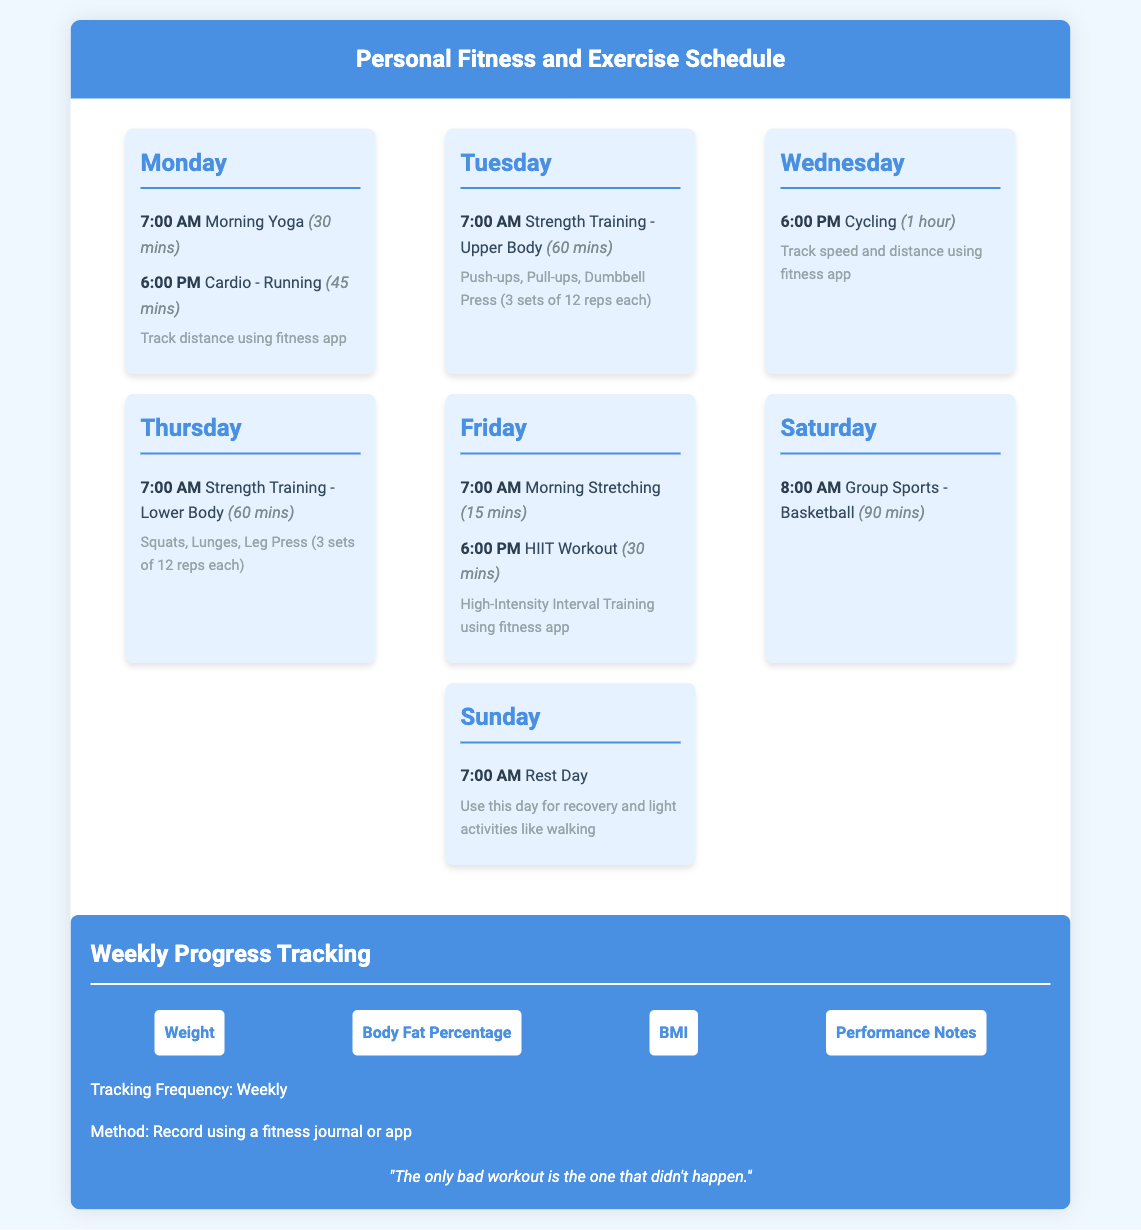What workout is scheduled for Monday at 7:00 AM? The document specifies that on Monday at 7:00 AM, there is a Morning Yoga workout scheduled for 30 minutes.
Answer: Morning Yoga How long is the HIIT Workout on Friday? The HIIT Workout on Friday is scheduled for 30 minutes according to the document.
Answer: 30 mins What type of strength training is done on Tuesday? On Tuesday, the strength training focuses on the upper body.
Answer: Upper Body How many days are scheduled for workouts in total? There are workouts scheduled for six days of the week, with Sunday designated as a rest day.
Answer: 6 days What is the purpose of the Sunday workout? The purpose of the Sunday workout is recovery and light activities.
Answer: Recovery What is the tracking frequency for weight metrics? The tracking frequency for weight metrics is weekly, as stated in the document.
Answer: Weekly What sport activity is planned for Saturday? The planned sport activity for Saturday is Basketball.
Answer: Basketball What time is the group sports session on Saturday? The group sports session on Saturday is scheduled for 8:00 AM.
Answer: 8:00 AM What fitness method is suggested for tracking progress? The document suggests using a fitness journal or app for tracking progress.
Answer: Fitness journal or app 